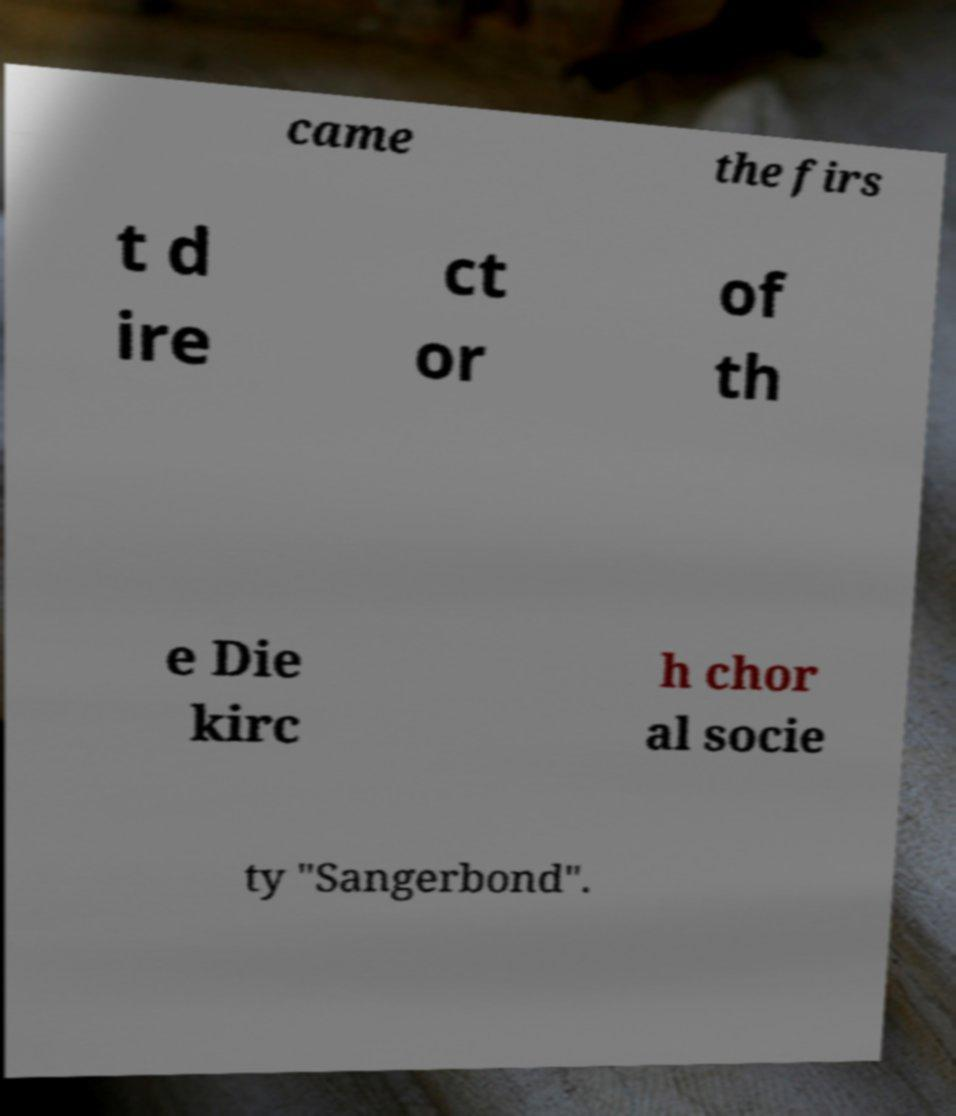Can you accurately transcribe the text from the provided image for me? came the firs t d ire ct or of th e Die kirc h chor al socie ty "Sangerbond". 